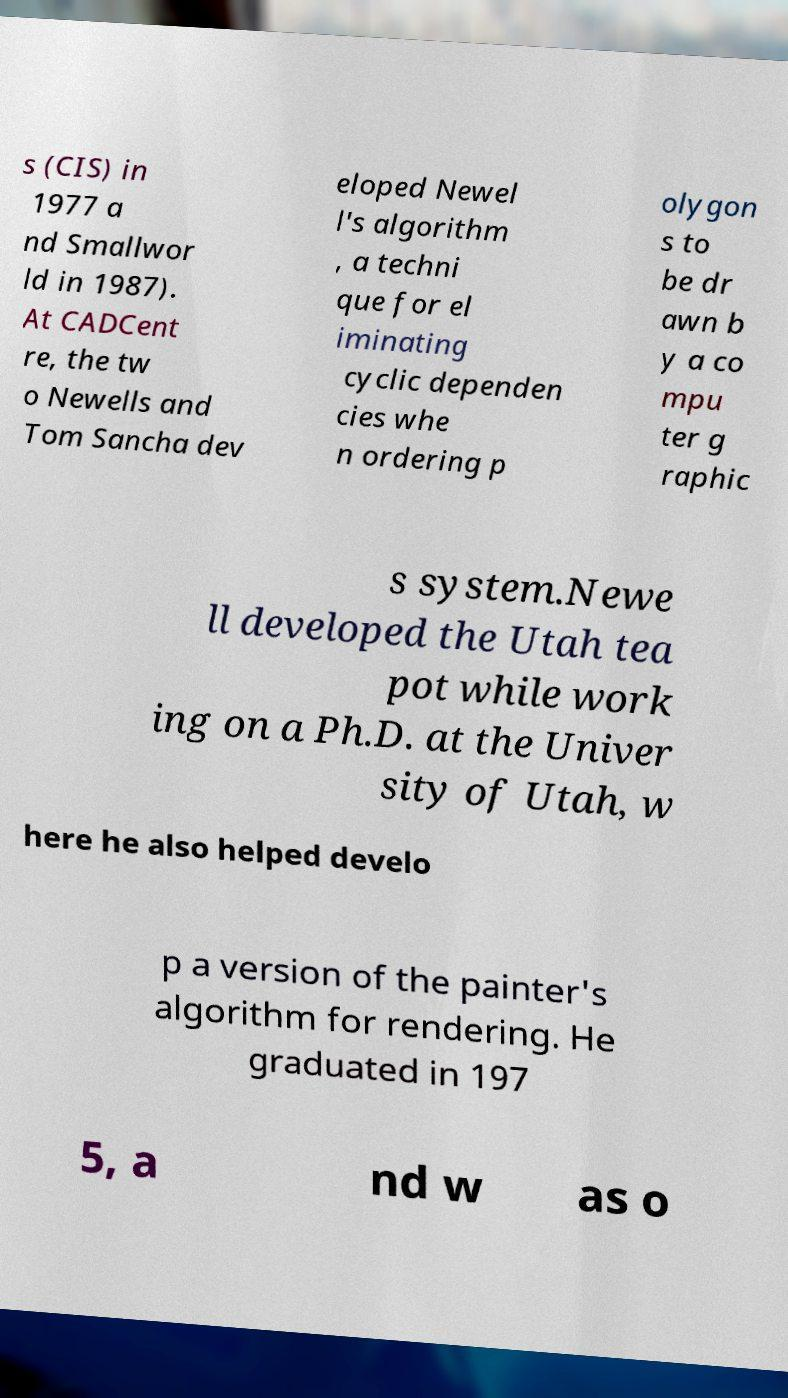There's text embedded in this image that I need extracted. Can you transcribe it verbatim? s (CIS) in 1977 a nd Smallwor ld in 1987). At CADCent re, the tw o Newells and Tom Sancha dev eloped Newel l's algorithm , a techni que for el iminating cyclic dependen cies whe n ordering p olygon s to be dr awn b y a co mpu ter g raphic s system.Newe ll developed the Utah tea pot while work ing on a Ph.D. at the Univer sity of Utah, w here he also helped develo p a version of the painter's algorithm for rendering. He graduated in 197 5, a nd w as o 